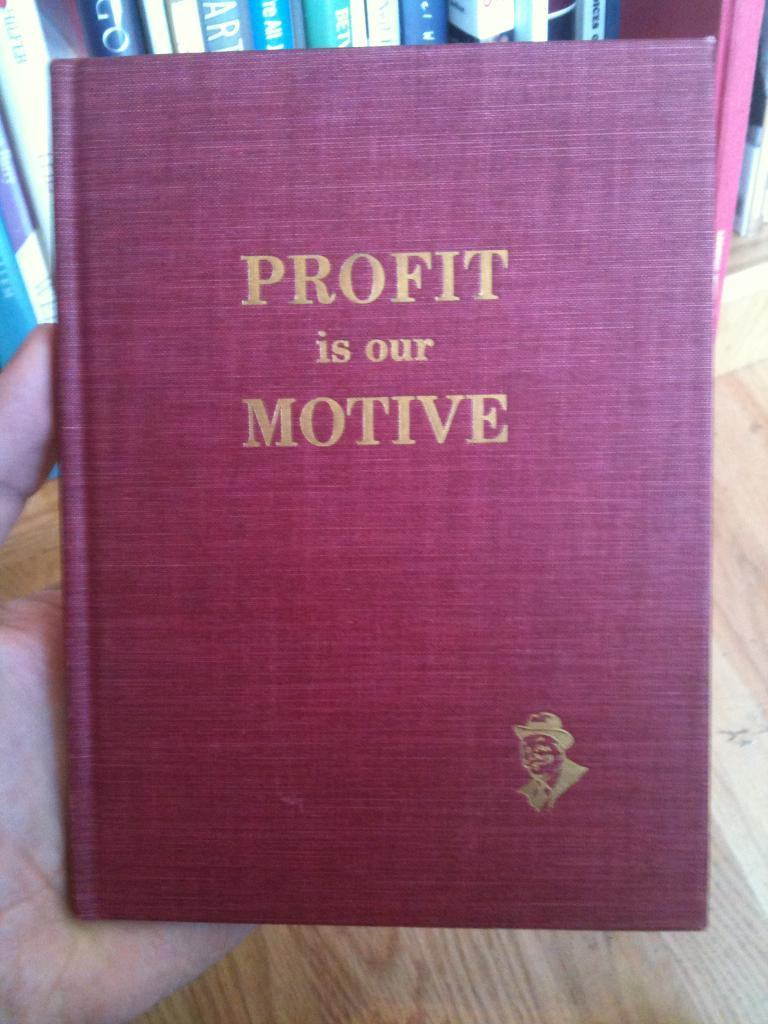Provide a one-sentence caption for the provided image. A red book with gold writing entitled Profit is our Motive. 